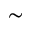Convert formula to latex. <formula><loc_0><loc_0><loc_500><loc_500>\sim</formula> 